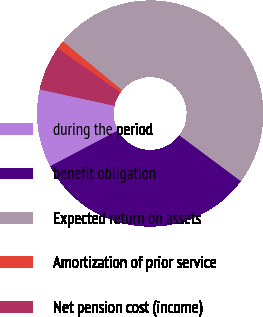Convert chart to OTSL. <chart><loc_0><loc_0><loc_500><loc_500><pie_chart><fcel>during the period<fcel>benefit obligation<fcel>Expected return on assets<fcel>Amortization of prior service<fcel>Net pension cost (income)<nl><fcel>11.15%<fcel>32.08%<fcel>49.22%<fcel>1.21%<fcel>6.35%<nl></chart> 